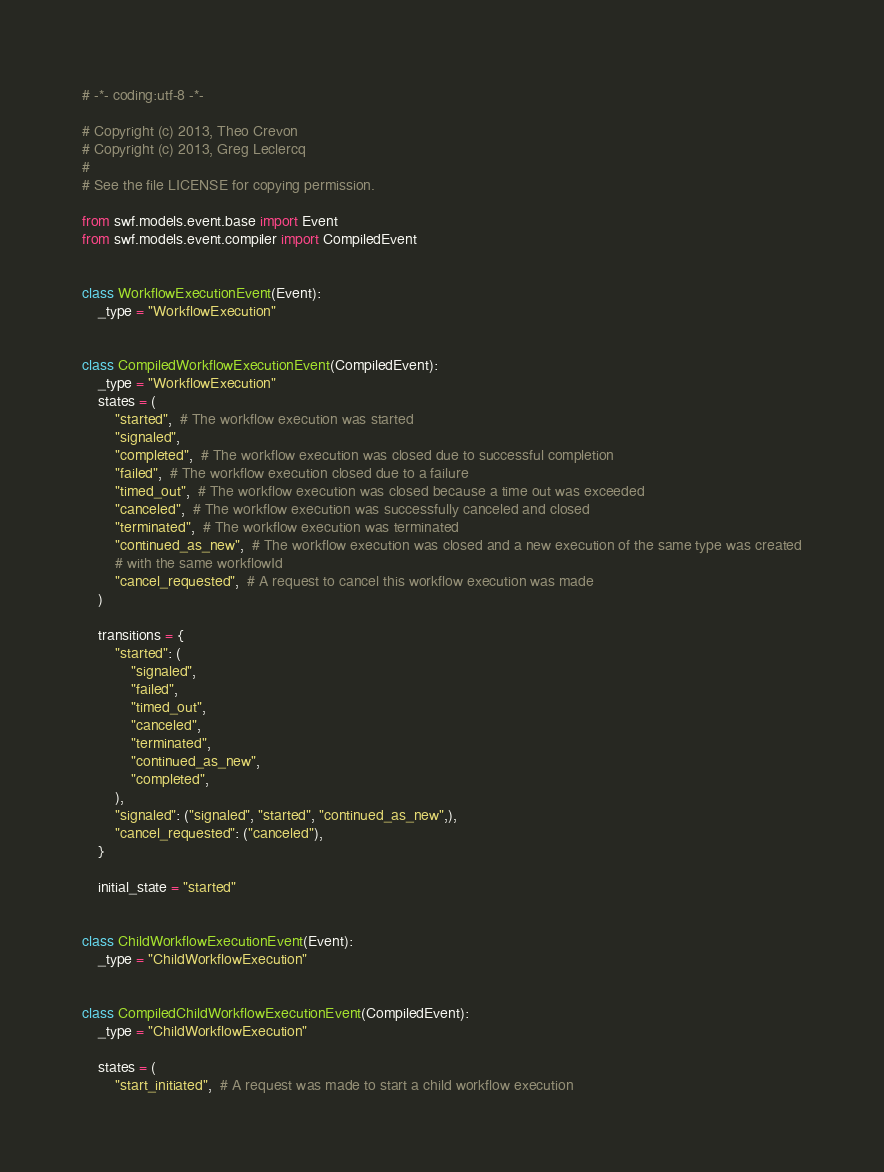Convert code to text. <code><loc_0><loc_0><loc_500><loc_500><_Python_># -*- coding:utf-8 -*-

# Copyright (c) 2013, Theo Crevon
# Copyright (c) 2013, Greg Leclercq
#
# See the file LICENSE for copying permission.

from swf.models.event.base import Event
from swf.models.event.compiler import CompiledEvent


class WorkflowExecutionEvent(Event):
    _type = "WorkflowExecution"


class CompiledWorkflowExecutionEvent(CompiledEvent):
    _type = "WorkflowExecution"
    states = (
        "started",  # The workflow execution was started
        "signaled",
        "completed",  # The workflow execution was closed due to successful completion
        "failed",  # The workflow execution closed due to a failure
        "timed_out",  # The workflow execution was closed because a time out was exceeded
        "canceled",  # The workflow execution was successfully canceled and closed
        "terminated",  # The workflow execution was terminated
        "continued_as_new",  # The workflow execution was closed and a new execution of the same type was created
        # with the same workflowId
        "cancel_requested",  # A request to cancel this workflow execution was made
    )

    transitions = {
        "started": (
            "signaled",
            "failed",
            "timed_out",
            "canceled",
            "terminated",
            "continued_as_new",
            "completed",
        ),
        "signaled": ("signaled", "started", "continued_as_new",),
        "cancel_requested": ("canceled"),
    }

    initial_state = "started"


class ChildWorkflowExecutionEvent(Event):
    _type = "ChildWorkflowExecution"


class CompiledChildWorkflowExecutionEvent(CompiledEvent):
    _type = "ChildWorkflowExecution"

    states = (
        "start_initiated",  # A request was made to start a child workflow execution</code> 